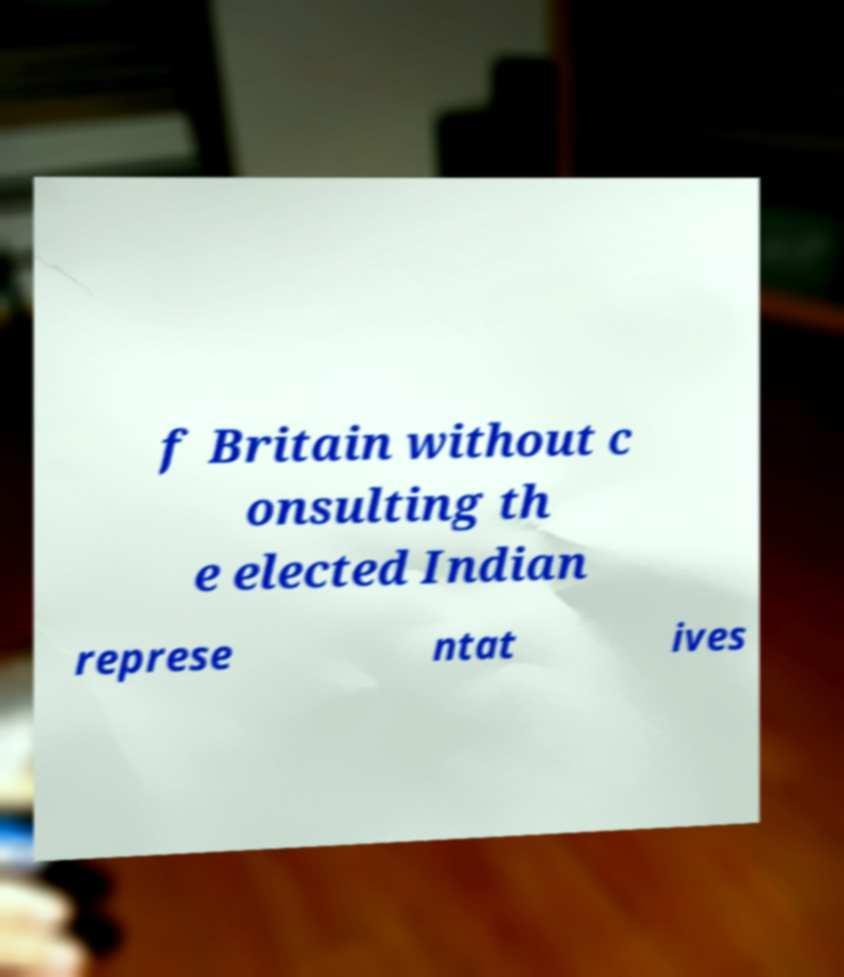Can you read and provide the text displayed in the image?This photo seems to have some interesting text. Can you extract and type it out for me? f Britain without c onsulting th e elected Indian represe ntat ives 